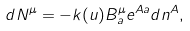<formula> <loc_0><loc_0><loc_500><loc_500>d N ^ { \mu } = - k ( u ) B _ { a } ^ { \mu } e ^ { A a } d n ^ { A } ,</formula> 